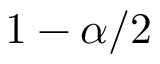Convert formula to latex. <formula><loc_0><loc_0><loc_500><loc_500>1 - \alpha / 2</formula> 